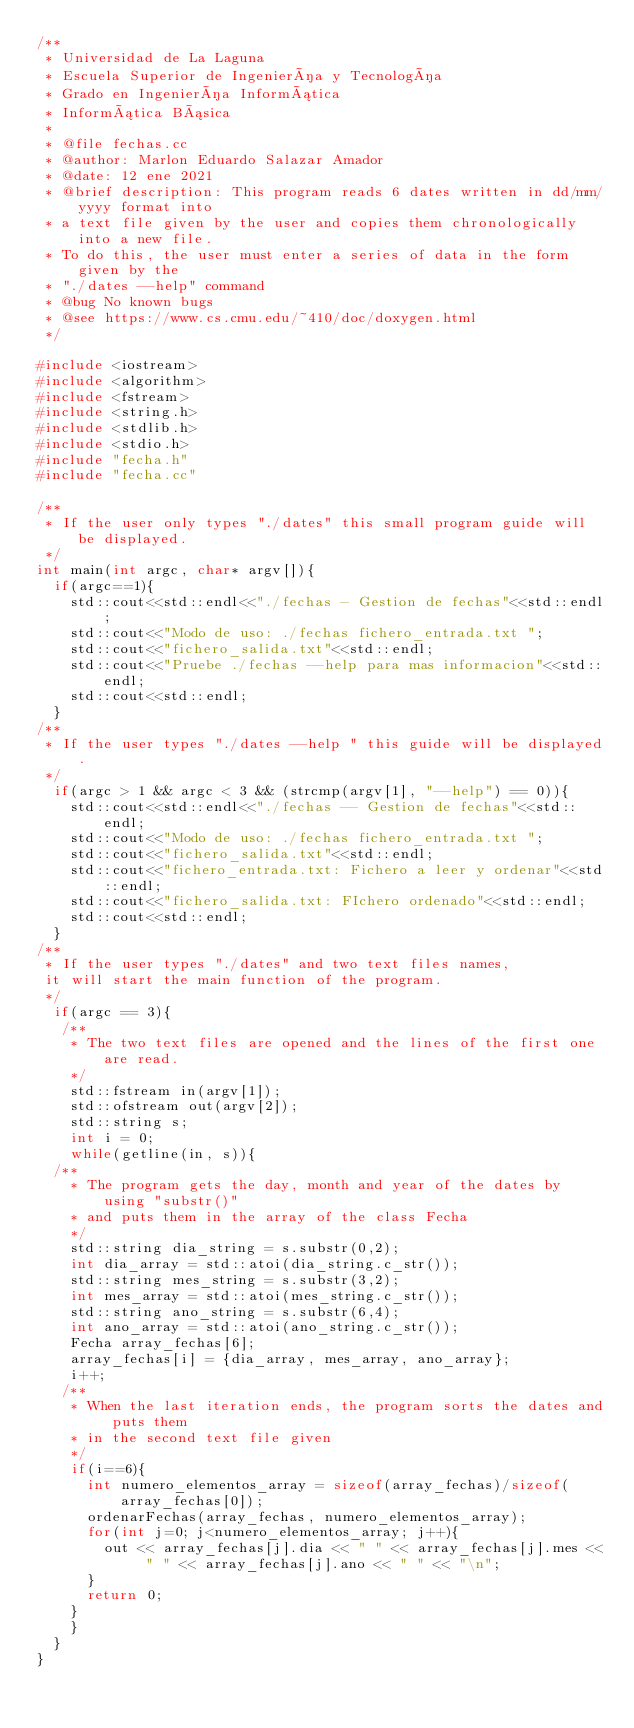<code> <loc_0><loc_0><loc_500><loc_500><_C++_>/**
 * Universidad de La Laguna
 * Escuela Superior de Ingeniería y Tecnología
 * Grado en Ingeniería Informática
 * Informática Básica
 *
 * @file fechas.cc
 * @author: Marlon Eduardo Salazar Amador
 * @date: 12 ene 2021
 * @brief description: This program reads 6 dates written in dd/mm/yyyy format into
 * a text file given by the user and copies them chronologically into a new file.
 * To do this, the user must enter a series of data in the form given by the
 * "./dates --help" command
 * @bug No known bugs
 * @see https://www.cs.cmu.edu/~410/doc/doxygen.html
 */

#include <iostream>
#include <algorithm>
#include <fstream>
#include <string.h>
#include <stdlib.h>
#include <stdio.h>
#include "fecha.h"
#include "fecha.cc"

/**
 * If the user only types "./dates" this small program guide will be displayed.
 */
int main(int argc, char* argv[]){
  if(argc==1){
    std::cout<<std::endl<<"./fechas - Gestion de fechas"<<std::endl;
    std::cout<<"Modo de uso: ./fechas fichero_entrada.txt ";
    std::cout<<"fichero_salida.txt"<<std::endl;
    std::cout<<"Pruebe ./fechas --help para mas informacion"<<std::endl;
    std::cout<<std::endl;
  }
/**
 * If the user types "./dates --help " this guide will be displayed.
 */
  if(argc > 1 && argc < 3 && (strcmp(argv[1], "--help") == 0)){
    std::cout<<std::endl<<"./fechas -- Gestion de fechas"<<std::endl;
    std::cout<<"Modo de uso: ./fechas fichero_entrada.txt ";
    std::cout<<"fichero_salida.txt"<<std::endl;
    std::cout<<"fichero_entrada.txt: Fichero a leer y ordenar"<<std::endl;
    std::cout<<"fichero_salida.txt: FIchero ordenado"<<std::endl;
    std::cout<<std::endl;
  }
/**
 * If the user types "./dates" and two text files names,
 it will start the main function of the program.
 */
  if(argc == 3){
   /**
    * The two text files are opened and the lines of the first one are read.
    */
    std::fstream in(argv[1]);
    std::ofstream out(argv[2]);
    std::string s;
    int i = 0;
    while(getline(in, s)){
  /**
    * The program gets the day, month and year of the dates by using "substr()"
    * and puts them in the array of the class Fecha
    */
    std::string dia_string = s.substr(0,2);
    int dia_array = std::atoi(dia_string.c_str());
    std::string mes_string = s.substr(3,2);
    int mes_array = std::atoi(mes_string.c_str());
    std::string ano_string = s.substr(6,4);
    int ano_array = std::atoi(ano_string.c_str());
    Fecha array_fechas[6];
    array_fechas[i] = {dia_array, mes_array, ano_array};
    i++;
   /**
    * When the last iteration ends, the program sorts the dates and puts them
    * in the second text file given
    */
    if(i==6){
      int numero_elementos_array = sizeof(array_fechas)/sizeof(array_fechas[0]);
      ordenarFechas(array_fechas, numero_elementos_array);
      for(int j=0; j<numero_elementos_array; j++){
        out << array_fechas[j].dia << " " << array_fechas[j].mes << " " << array_fechas[j].ano << " " << "\n";
      }
      return 0;
    }
    }
  }
}
</code> 